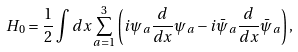<formula> <loc_0><loc_0><loc_500><loc_500>H _ { 0 } = \frac { 1 } { 2 } \int d x \sum _ { a = 1 } ^ { 3 } \left ( i \psi _ { a } \frac { d } { d x } \psi _ { a } - i \bar { \psi } _ { a } \frac { d } { d x } \bar { \psi } _ { a } \right ) ,</formula> 